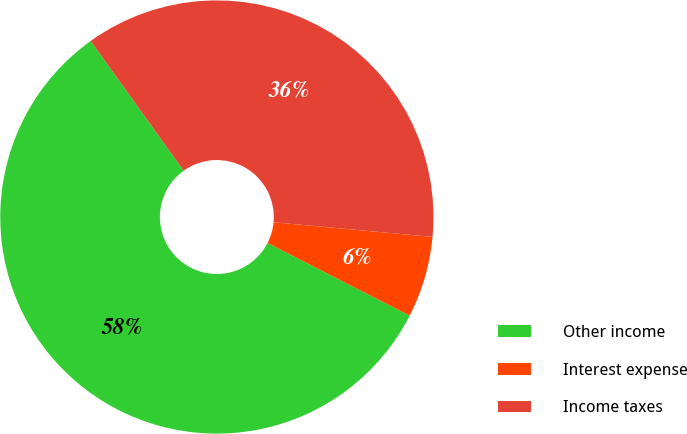Convert chart. <chart><loc_0><loc_0><loc_500><loc_500><pie_chart><fcel>Other income<fcel>Interest expense<fcel>Income taxes<nl><fcel>57.58%<fcel>6.06%<fcel>36.36%<nl></chart> 